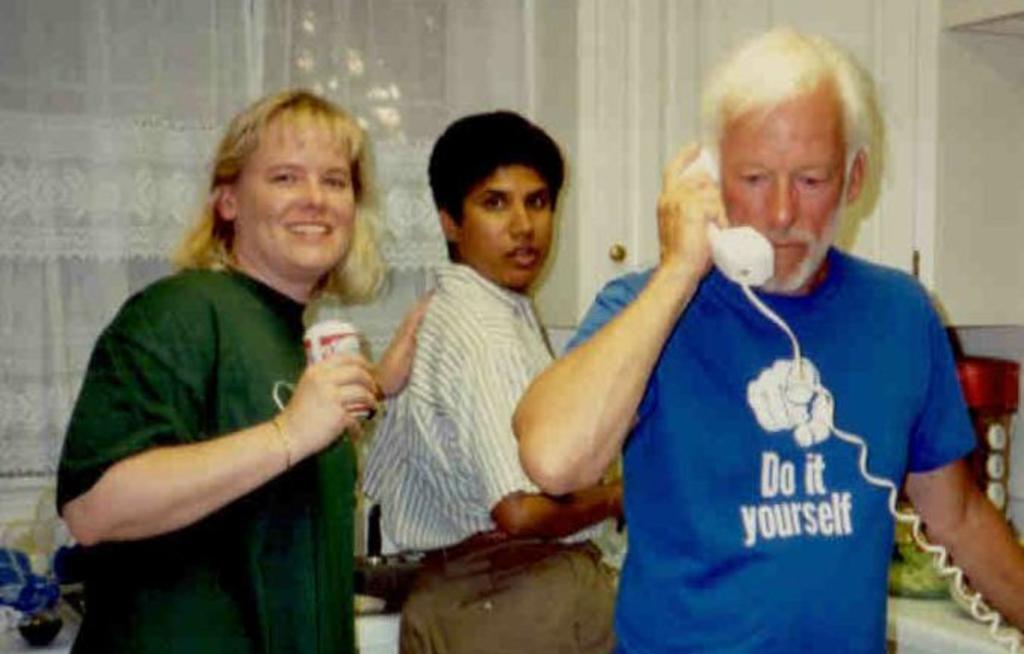Could you give a brief overview of what you see in this image? As we can see in the image there are three people. The man standing on the right side is wearing blue color t shirt and holding a telephone 